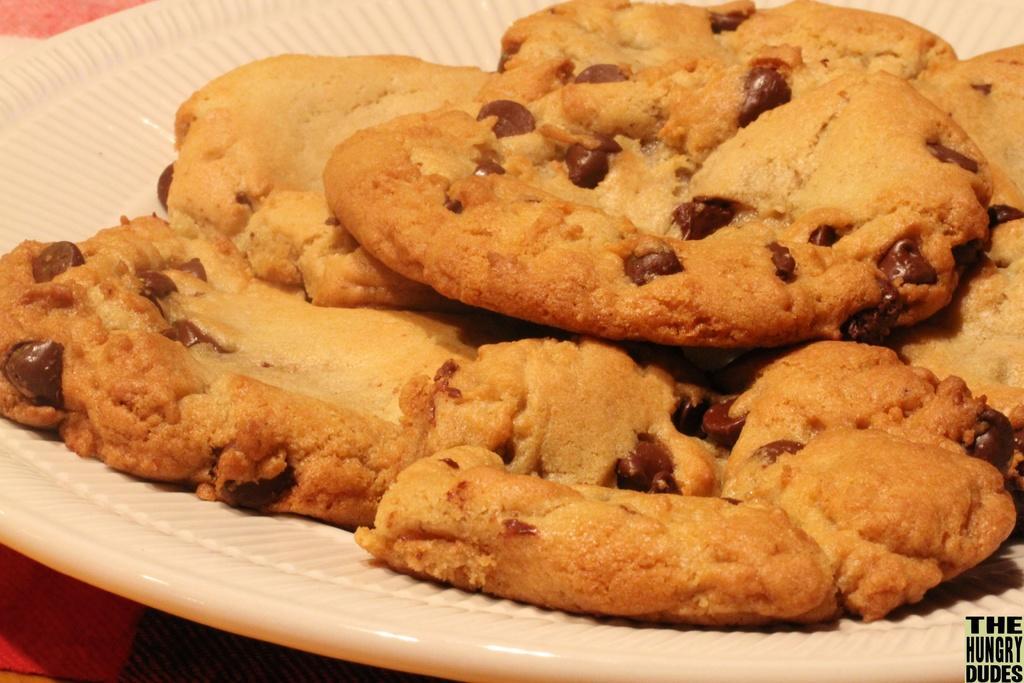How would you summarize this image in a sentence or two? In this picture, we see a white plate containing the cookies. In the left bottom, we see something in red color. 